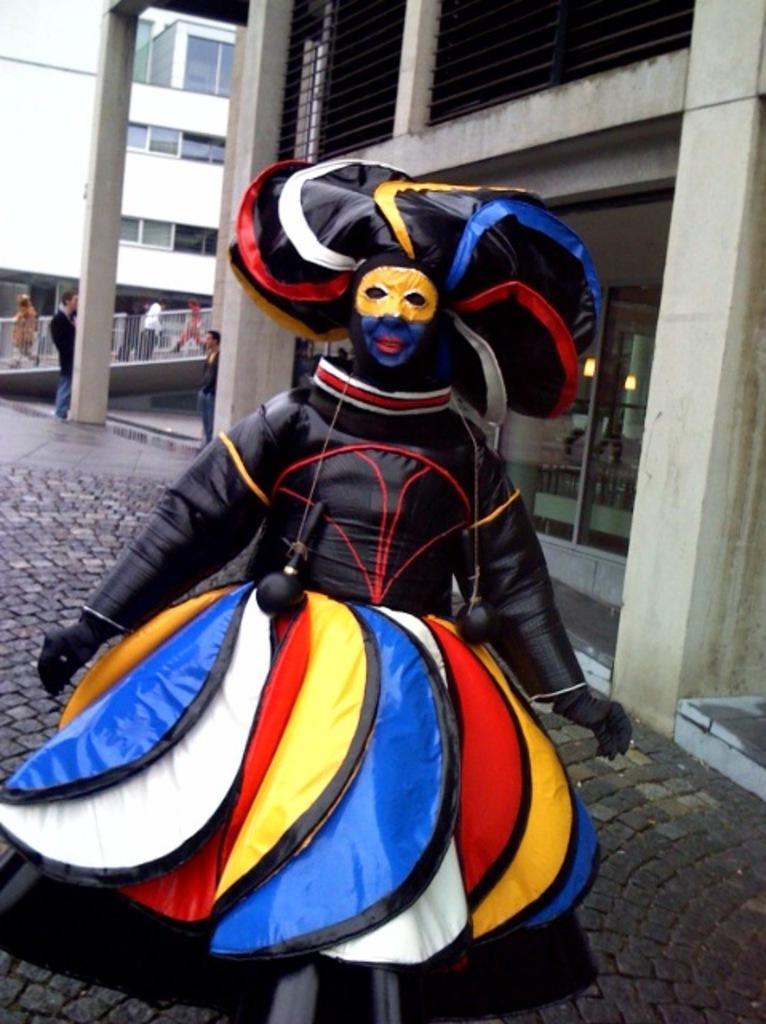Describe this image in one or two sentences. In the image there is a person standing in the front in a black and colorful costume with a building behind him, on the left side there are few people walking. 